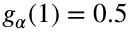<formula> <loc_0><loc_0><loc_500><loc_500>g _ { \alpha } ( 1 ) = 0 . 5</formula> 